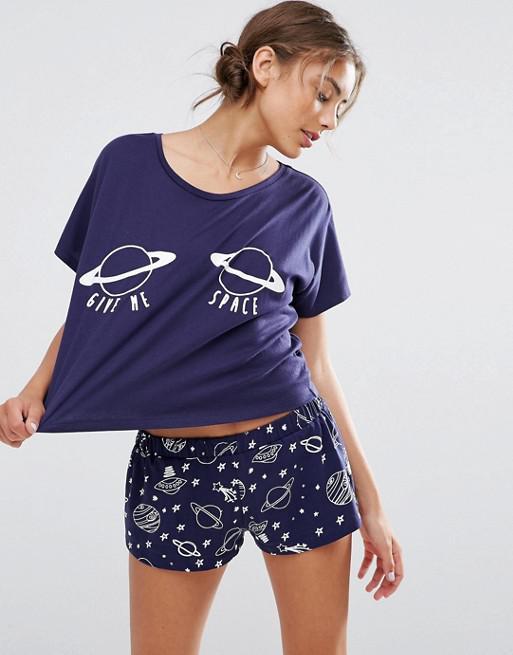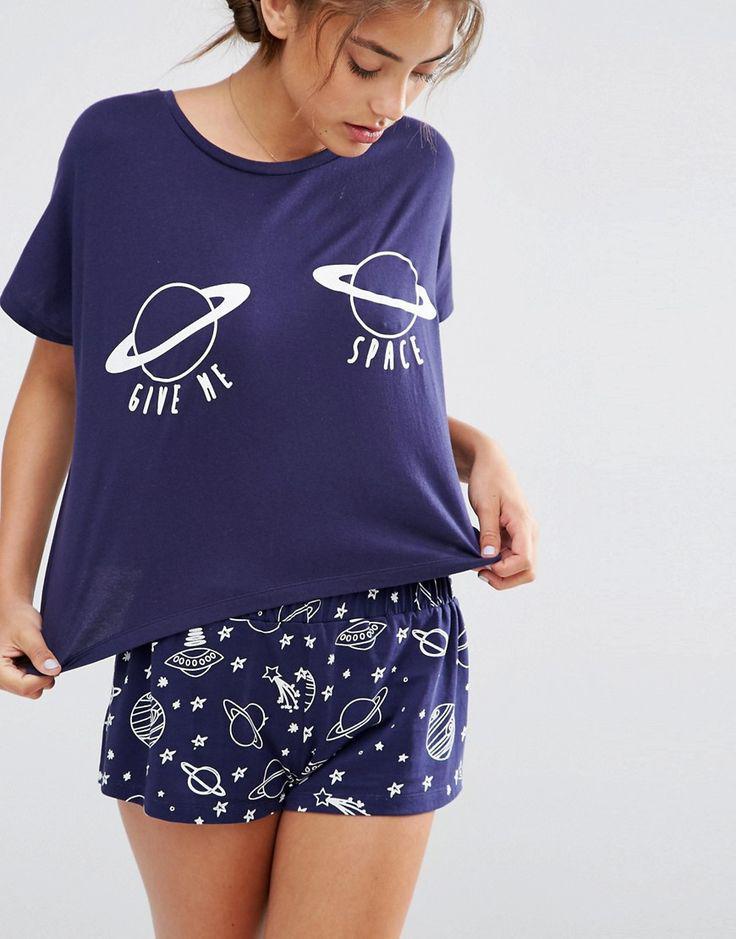The first image is the image on the left, the second image is the image on the right. Assess this claim about the two images: "Left and right images feature models wearing same style outfits.". Correct or not? Answer yes or no. Yes. The first image is the image on the left, the second image is the image on the right. For the images displayed, is the sentence "There is a woman wearing a pajama top with no sleeves and a pair of pajama shorts." factually correct? Answer yes or no. No. 